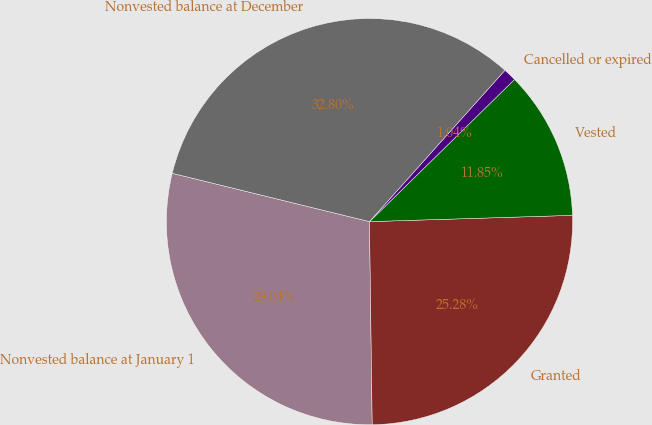Convert chart to OTSL. <chart><loc_0><loc_0><loc_500><loc_500><pie_chart><fcel>Nonvested balance at January 1<fcel>Granted<fcel>Vested<fcel>Cancelled or expired<fcel>Nonvested balance at December<nl><fcel>29.04%<fcel>25.28%<fcel>11.85%<fcel>1.04%<fcel>32.8%<nl></chart> 